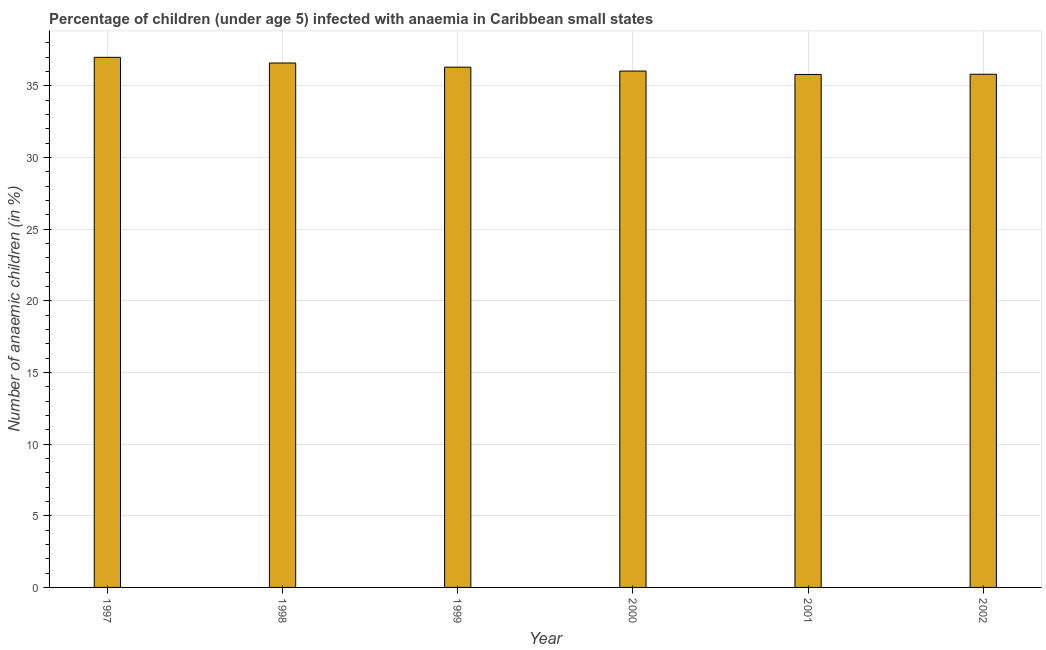What is the title of the graph?
Your response must be concise. Percentage of children (under age 5) infected with anaemia in Caribbean small states. What is the label or title of the X-axis?
Your response must be concise. Year. What is the label or title of the Y-axis?
Offer a very short reply. Number of anaemic children (in %). What is the number of anaemic children in 1997?
Make the answer very short. 36.99. Across all years, what is the maximum number of anaemic children?
Offer a very short reply. 36.99. Across all years, what is the minimum number of anaemic children?
Provide a succinct answer. 35.79. What is the sum of the number of anaemic children?
Your response must be concise. 217.5. What is the difference between the number of anaemic children in 1997 and 1999?
Provide a succinct answer. 0.69. What is the average number of anaemic children per year?
Keep it short and to the point. 36.25. What is the median number of anaemic children?
Provide a succinct answer. 36.16. What is the ratio of the number of anaemic children in 2001 to that in 2002?
Keep it short and to the point. 1. Is the number of anaemic children in 1999 less than that in 2000?
Provide a short and direct response. No. Is the difference between the number of anaemic children in 2000 and 2002 greater than the difference between any two years?
Keep it short and to the point. No. What is the difference between the highest and the second highest number of anaemic children?
Your response must be concise. 0.4. Is the sum of the number of anaemic children in 1997 and 1999 greater than the maximum number of anaemic children across all years?
Keep it short and to the point. Yes. What is the difference between the highest and the lowest number of anaemic children?
Your response must be concise. 1.19. How many bars are there?
Offer a very short reply. 6. How many years are there in the graph?
Provide a succinct answer. 6. What is the difference between two consecutive major ticks on the Y-axis?
Provide a succinct answer. 5. What is the Number of anaemic children (in %) in 1997?
Keep it short and to the point. 36.99. What is the Number of anaemic children (in %) of 1998?
Provide a succinct answer. 36.59. What is the Number of anaemic children (in %) of 1999?
Offer a terse response. 36.3. What is the Number of anaemic children (in %) of 2000?
Your response must be concise. 36.03. What is the Number of anaemic children (in %) of 2001?
Keep it short and to the point. 35.79. What is the Number of anaemic children (in %) of 2002?
Provide a succinct answer. 35.8. What is the difference between the Number of anaemic children (in %) in 1997 and 1998?
Provide a succinct answer. 0.39. What is the difference between the Number of anaemic children (in %) in 1997 and 1999?
Offer a very short reply. 0.69. What is the difference between the Number of anaemic children (in %) in 1997 and 2000?
Ensure brevity in your answer.  0.96. What is the difference between the Number of anaemic children (in %) in 1997 and 2001?
Your answer should be compact. 1.19. What is the difference between the Number of anaemic children (in %) in 1997 and 2002?
Your answer should be very brief. 1.18. What is the difference between the Number of anaemic children (in %) in 1998 and 1999?
Make the answer very short. 0.29. What is the difference between the Number of anaemic children (in %) in 1998 and 2000?
Keep it short and to the point. 0.56. What is the difference between the Number of anaemic children (in %) in 1998 and 2001?
Ensure brevity in your answer.  0.8. What is the difference between the Number of anaemic children (in %) in 1998 and 2002?
Provide a succinct answer. 0.79. What is the difference between the Number of anaemic children (in %) in 1999 and 2000?
Your answer should be very brief. 0.27. What is the difference between the Number of anaemic children (in %) in 1999 and 2001?
Make the answer very short. 0.51. What is the difference between the Number of anaemic children (in %) in 1999 and 2002?
Your answer should be compact. 0.5. What is the difference between the Number of anaemic children (in %) in 2000 and 2001?
Provide a short and direct response. 0.24. What is the difference between the Number of anaemic children (in %) in 2000 and 2002?
Provide a succinct answer. 0.22. What is the difference between the Number of anaemic children (in %) in 2001 and 2002?
Your answer should be very brief. -0.01. What is the ratio of the Number of anaemic children (in %) in 1997 to that in 2001?
Make the answer very short. 1.03. What is the ratio of the Number of anaemic children (in %) in 1997 to that in 2002?
Keep it short and to the point. 1.03. What is the ratio of the Number of anaemic children (in %) in 1998 to that in 2000?
Keep it short and to the point. 1.02. What is the ratio of the Number of anaemic children (in %) in 1999 to that in 2001?
Your answer should be compact. 1.01. What is the ratio of the Number of anaemic children (in %) in 1999 to that in 2002?
Offer a terse response. 1.01. What is the ratio of the Number of anaemic children (in %) in 2000 to that in 2002?
Your answer should be compact. 1.01. 